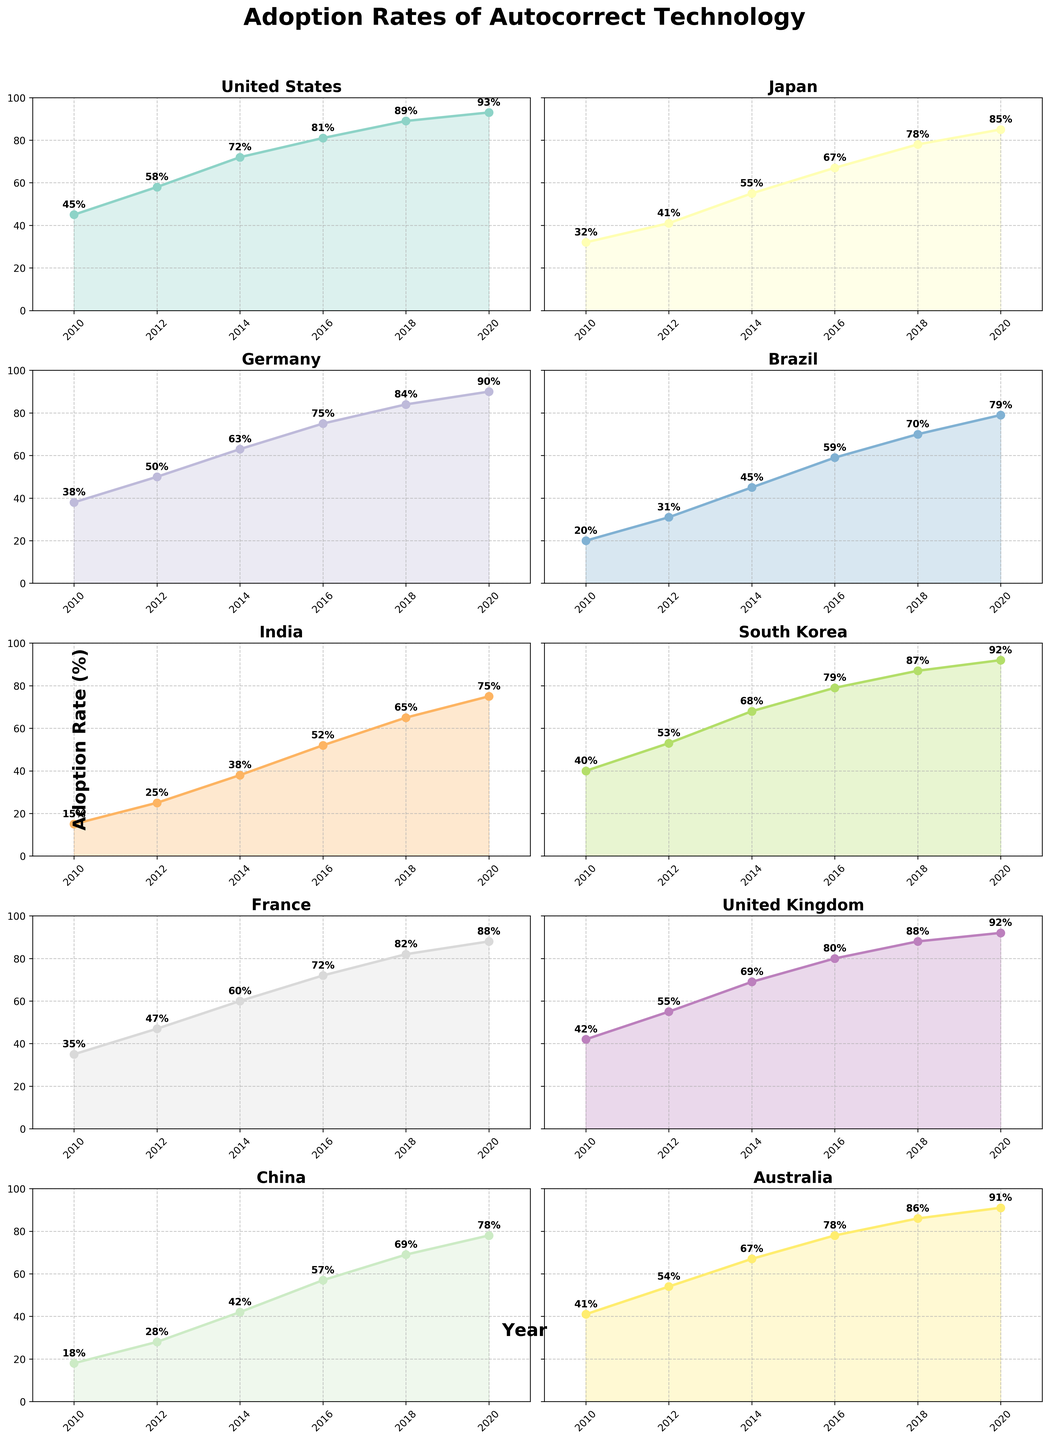What is the main title of the figure? The main title is usually positioned at the top of the figure and written in a larger, bold font. The main title is "Adoption Rates of Autocorrect Technology".
Answer: Adoption Rates of Autocorrect Technology How many subplots does the figure contain? The figure has 5 rows and 2 columns of subplots, so it contains 5 * 2 = 10 subplots in total.
Answer: 10 Which country had the highest adoption rate in 2020? By looking at the values in 2020 for each country's subplot, note which country has the highest percentage. South Korea and the United Kingdom both have an adoption rate of 92%, which is the highest among all countries.
Answer: South Korea and the United Kingdom What is the general trend of autocorrect adoption rates over time in all countries? Examine the plots for each country; the lines generally show an upward trend from 2010 to 2020, indicating that the adoption rates increased over this period.
Answer: Increasing Which country had the slowest adoption rate in 2010? Compare the adoption rates for all countries in the year 2010. India had the lowest adoption rate with 15%.
Answer: India How much did the adoption rate in Brazil increase from 2010 to 2020? The adoption rate in Brazil in 2010 was 20%, and in 2020 it was 79%. The increase is calculated as 79% - 20% = 59%.
Answer: 59% Which two countries have a similar adoption rate in 2018? Look at the 2018 data points for each country and identify which ones are close in value. Australia and South Korea both had adoption rates of 86% and 87%, respectively, which are very close.
Answer: Australia and South Korea Which country shows the steepest increase in adoption rate between 2012 and 2014? Calculate the differences between the adoption rates of 2012 and 2014 for each country, and see which one has the highest value. For India, the increase is 38% - 25% = 13%, which is the highest increase among all countries.
Answer: India What is the difference in adoption rates between the United States and China in 2020? In 2020, the adoption rates are 93% for the United States and 78% for China. The difference is 93% - 78% = 15%.
Answer: 15% Which country had the smallest change in adoption rate from 2016 to 2020? Calculate the differences between the adoption rates in 2016 and 2020 for each country. France had an adoption rate change from 72% to 88%, which is a change of 88% - 72% = 16%, the smallest among all countries.
Answer: France 